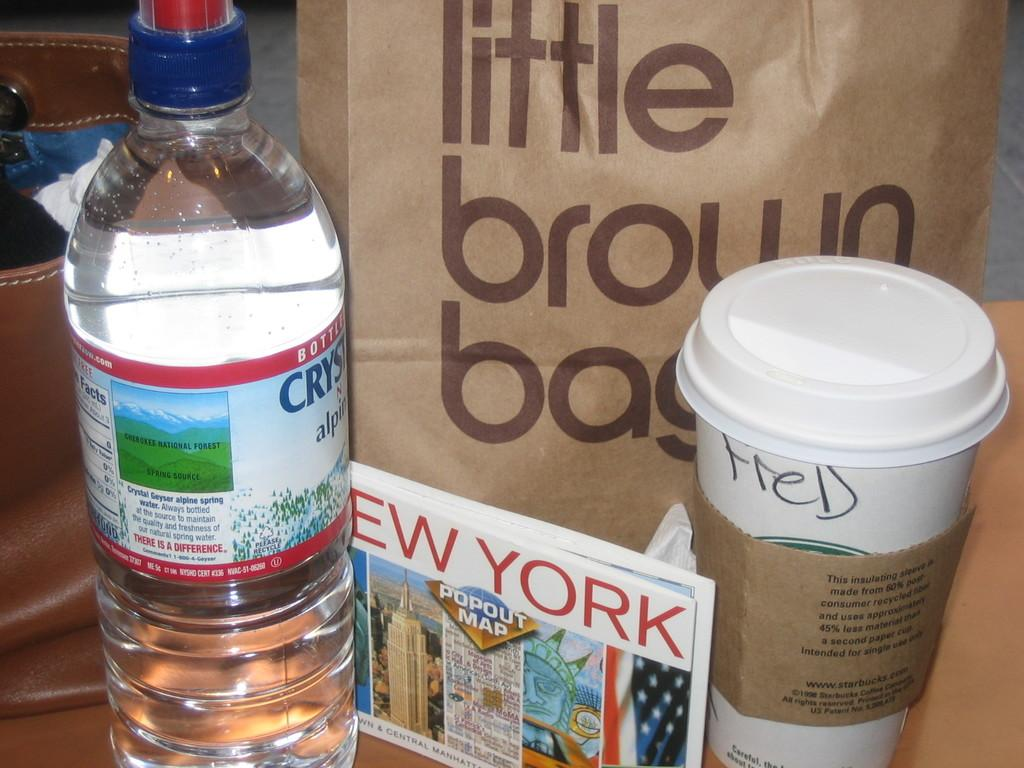What type of container is visible in the image? There is a water bottle in the image. What object can be used for writing or displaying information? There is a board in the image. What type of drinking vessel is present in the image? There is a glass in the image. What item might be used for carrying items? There is a carry bag in the image. What type of bag is visible in the image? There is a handbag in the image. Where is the swing located in the image? There is no swing present in the image. What type of bait is used for fishing in the image? There is no fishing or bait present in the image. 